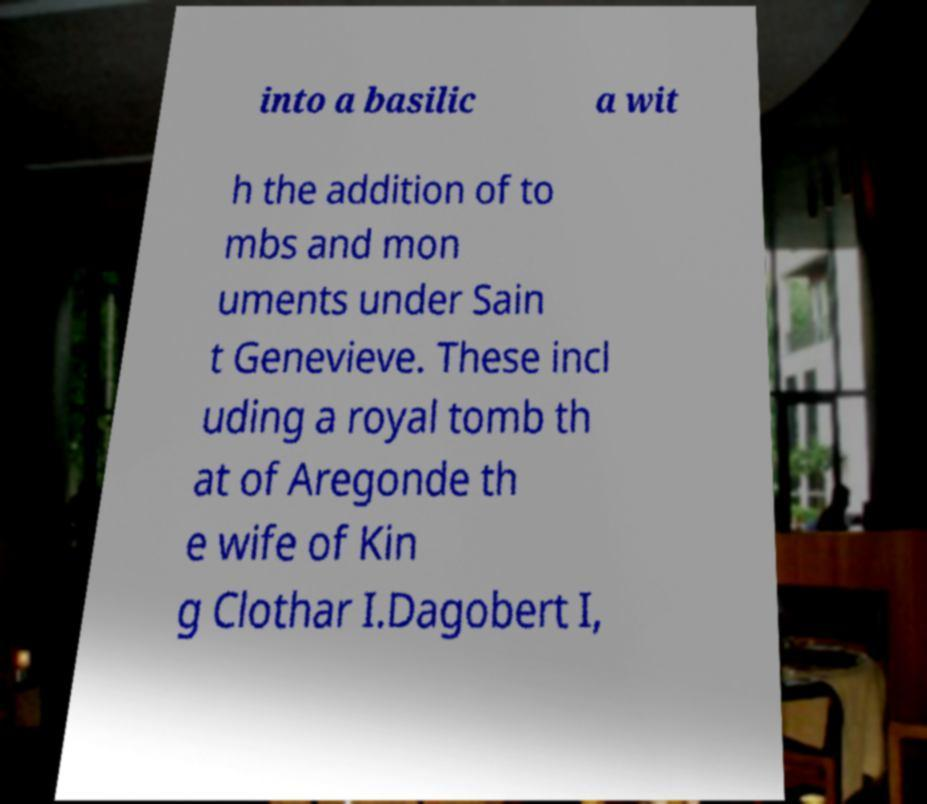Can you accurately transcribe the text from the provided image for me? into a basilic a wit h the addition of to mbs and mon uments under Sain t Genevieve. These incl uding a royal tomb th at of Aregonde th e wife of Kin g Clothar I.Dagobert I, 